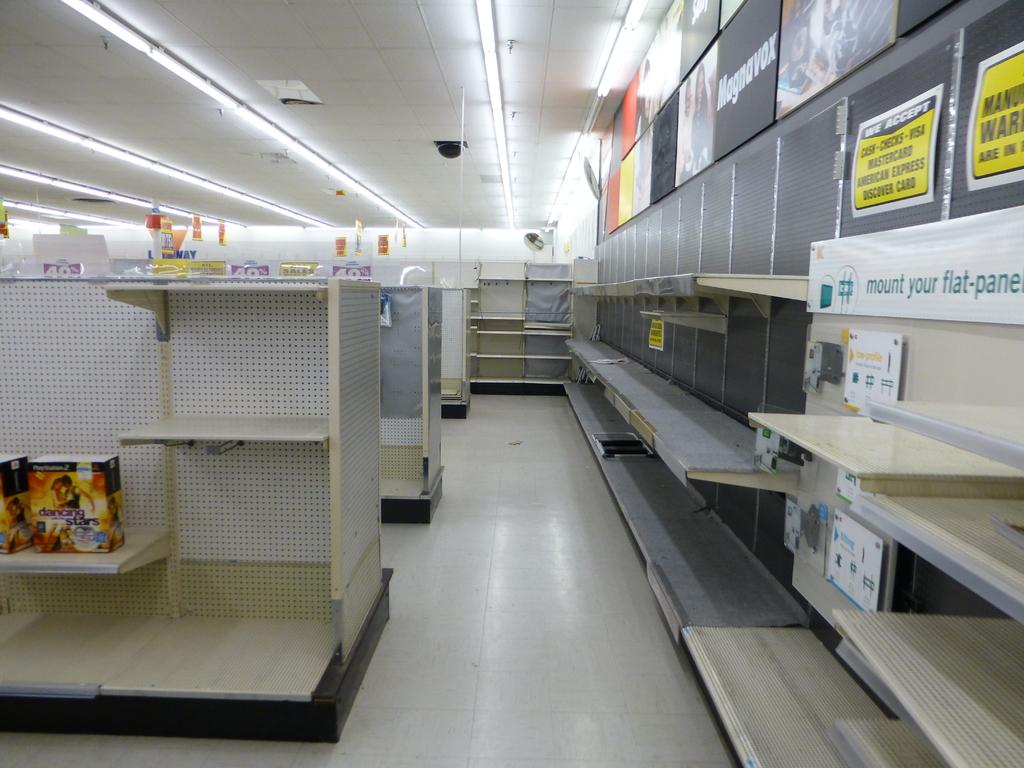<image>
Relay a brief, clear account of the picture shown. empty store shelves with wall banners directing where to mount the flat-panels 